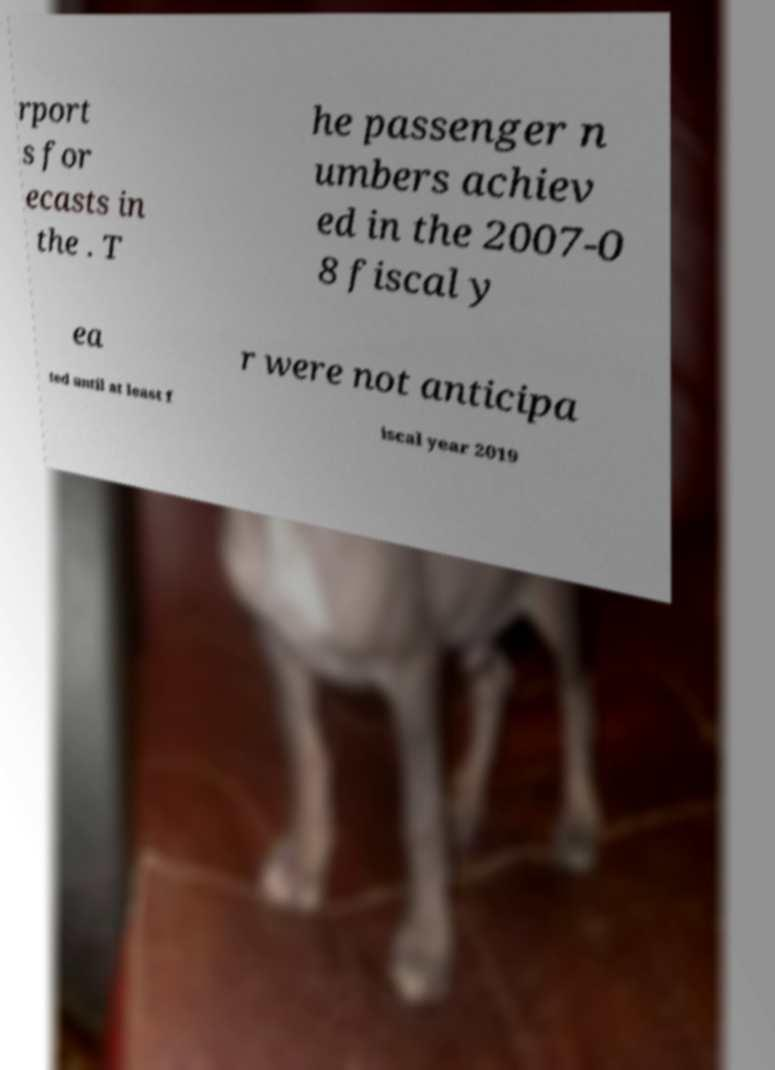Could you extract and type out the text from this image? rport s for ecasts in the . T he passenger n umbers achiev ed in the 2007-0 8 fiscal y ea r were not anticipa ted until at least f iscal year 2019 